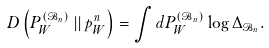Convert formula to latex. <formula><loc_0><loc_0><loc_500><loc_500>D \left ( P ^ { ( \mathcal { B } _ { n } ) } _ { W } \left | \right | p _ { W } ^ { n } \right ) = \int d P ^ { ( \mathcal { B } _ { n } ) } _ { W } \log \Delta _ { \mathcal { B } _ { n } } .</formula> 